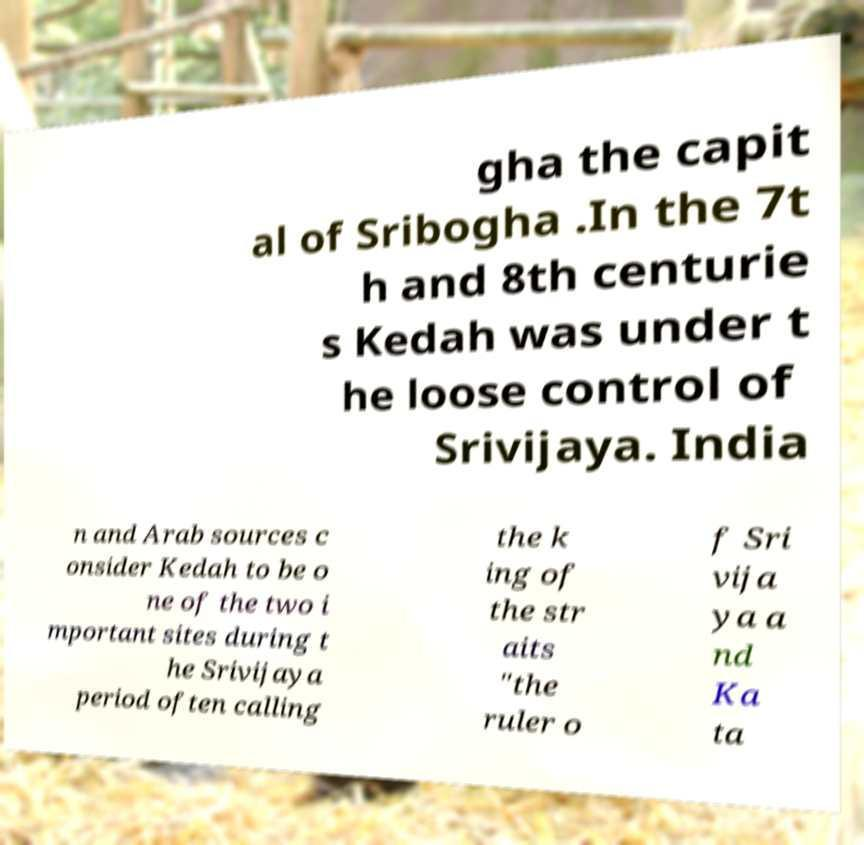Could you extract and type out the text from this image? gha the capit al of Sribogha .In the 7t h and 8th centurie s Kedah was under t he loose control of Srivijaya. India n and Arab sources c onsider Kedah to be o ne of the two i mportant sites during t he Srivijaya period often calling the k ing of the str aits "the ruler o f Sri vija ya a nd Ka ta 